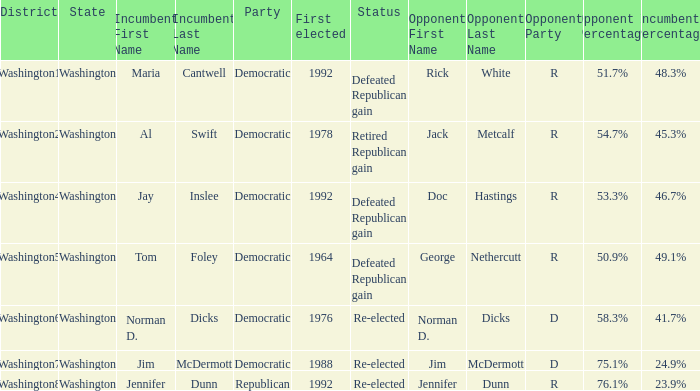Could you help me parse every detail presented in this table? {'header': ['District', 'State', 'Incumbent First Name', 'Incumbent Last Name', 'Party', 'First elected', 'Status', 'Opponent First Name', 'Opponent Last Name', 'Opponent Party', 'Opponent Percentage', 'Incumbent Percentage'], 'rows': [['Washington1', 'Washington', 'Maria', 'Cantwell', 'Democratic', '1992', 'Defeated Republican gain', 'Rick', 'White', 'R', '51.7%', '48.3%'], ['Washington2', 'Washington', 'Al', 'Swift', 'Democratic', '1978', 'Retired Republican gain', 'Jack', 'Metcalf', 'R', '54.7%', '45.3%'], ['Washington4', 'Washington', 'Jay', 'Inslee', 'Democratic', '1992', 'Defeated Republican gain', 'Doc', 'Hastings', 'R', '53.3%', '46.7%'], ['Washington5', 'Washington', 'Tom', 'Foley', 'Democratic', '1964', 'Defeated Republican gain', 'George', 'Nethercutt', 'R', '50.9%', '49.1%'], ['Washington6', 'Washington', 'Norman D.', 'Dicks', 'Democratic', '1976', 'Re-elected', 'Norman D.', 'Dicks', 'D', '58.3%', '41.7%'], ['Washington7', 'Washington', 'Jim', 'McDermott', 'Democratic', '1988', 'Re-elected', 'Jim', 'McDermott', 'D', '75.1%', '24.9%'], ['Washington8', 'Washington', 'Jennifer', 'Dunn', 'Republican', '1992', 'Re-elected', 'Jennifer', 'Dunn', 'R', '76.1%', '23.9%']]} What year was incumbent jim mcdermott first elected? 1988.0. 